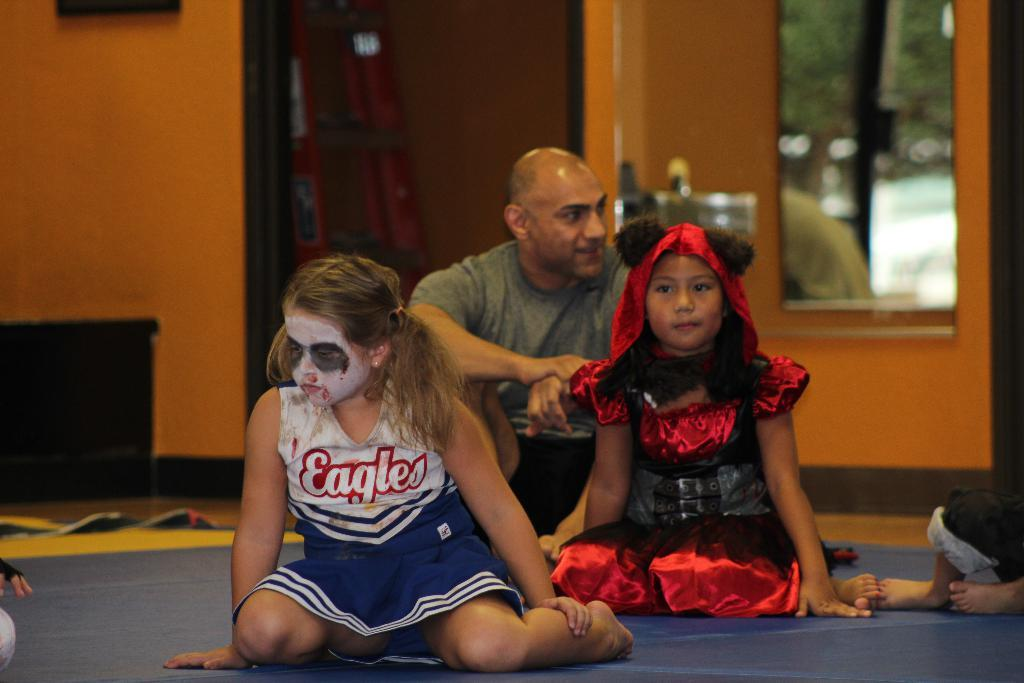<image>
Describe the image concisely. Young girl with white paint on her face and Eagles on her uniform. 